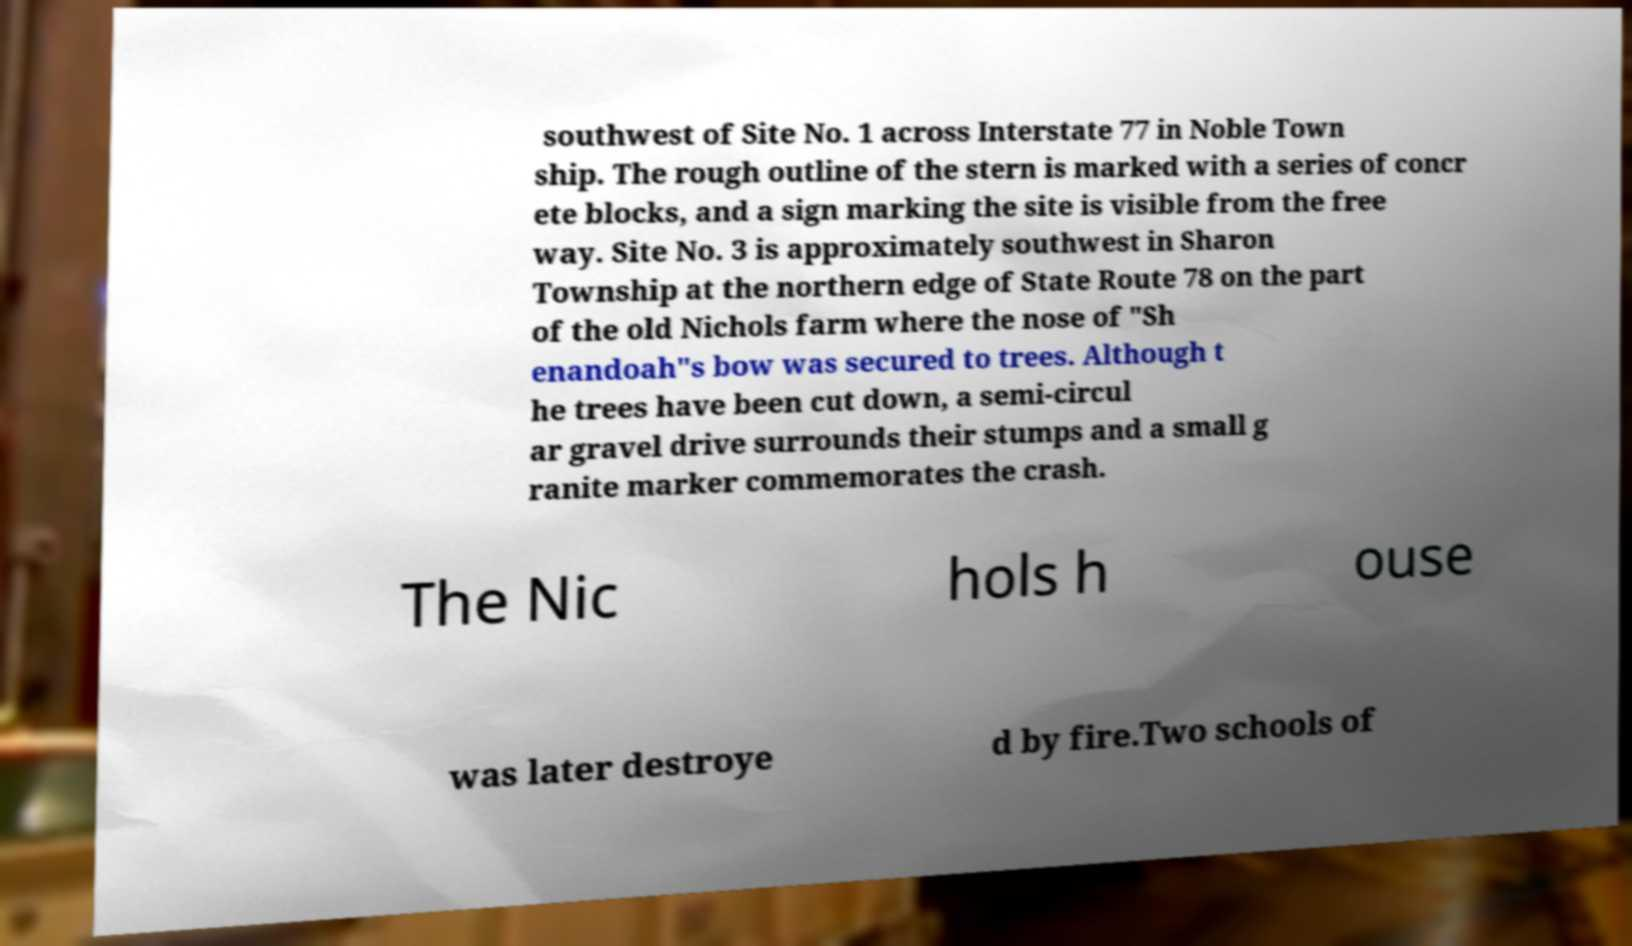What messages or text are displayed in this image? I need them in a readable, typed format. southwest of Site No. 1 across Interstate 77 in Noble Town ship. The rough outline of the stern is marked with a series of concr ete blocks, and a sign marking the site is visible from the free way. Site No. 3 is approximately southwest in Sharon Township at the northern edge of State Route 78 on the part of the old Nichols farm where the nose of "Sh enandoah"s bow was secured to trees. Although t he trees have been cut down, a semi-circul ar gravel drive surrounds their stumps and a small g ranite marker commemorates the crash. The Nic hols h ouse was later destroye d by fire.Two schools of 